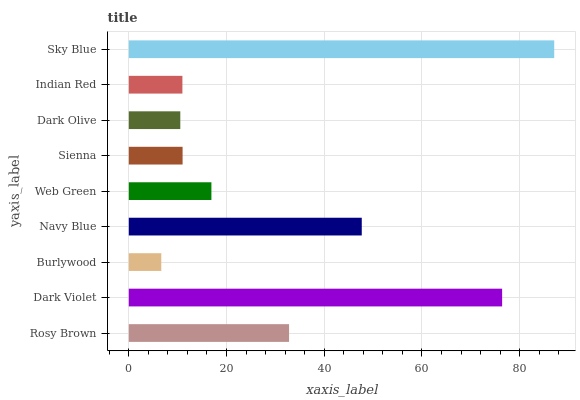Is Burlywood the minimum?
Answer yes or no. Yes. Is Sky Blue the maximum?
Answer yes or no. Yes. Is Dark Violet the minimum?
Answer yes or no. No. Is Dark Violet the maximum?
Answer yes or no. No. Is Dark Violet greater than Rosy Brown?
Answer yes or no. Yes. Is Rosy Brown less than Dark Violet?
Answer yes or no. Yes. Is Rosy Brown greater than Dark Violet?
Answer yes or no. No. Is Dark Violet less than Rosy Brown?
Answer yes or no. No. Is Web Green the high median?
Answer yes or no. Yes. Is Web Green the low median?
Answer yes or no. Yes. Is Burlywood the high median?
Answer yes or no. No. Is Indian Red the low median?
Answer yes or no. No. 